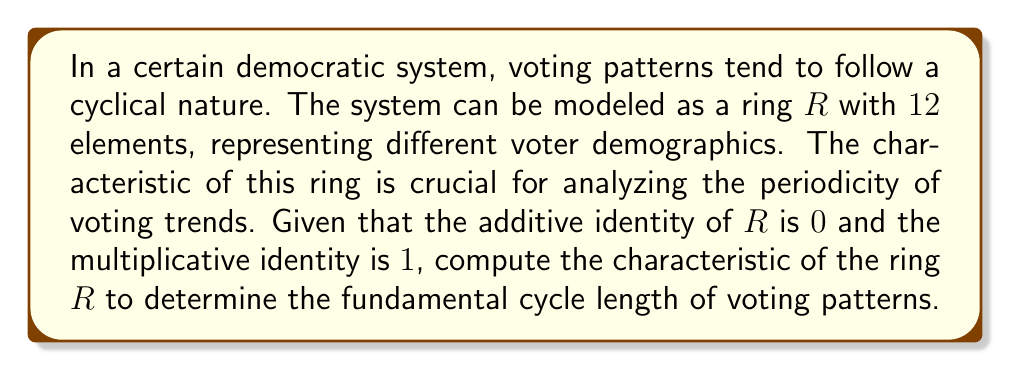Solve this math problem. To compute the characteristic of a ring $R$, we need to find the smallest positive integer $n$ such that:

$$n \cdot 1 = 0$$

where $1$ is the multiplicative identity and $0$ is the additive identity of the ring.

Let's proceed step-by-step:

1) We start by adding $1$ to itself repeatedly:

   $1 + 1 = 2$
   $2 + 1 = 3$
   $3 + 1 = 4$
   ...

2) We continue this process until we reach $0$:

   $10 + 1 = 11$
   $11 + 1 = 0$

3) We found that $12 \cdot 1 = 0$

4) Now, we need to check if there's any smaller positive integer that satisfies this condition:

   $6 \cdot 1 = 6 \neq 0$
   $4 \cdot 1 = 4 \neq 0$
   $3 \cdot 1 = 3 \neq 0$
   $2 \cdot 1 = 2 \neq 0$

5) Since no smaller positive integer satisfies the condition, we conclude that the characteristic of the ring is 12.

This result indicates that the voting patterns in this system have a fundamental cycle length of 12, which could represent, for example, a 12-year cycle in voter behavior or preferences.
Answer: The characteristic of the ring $R$ is $12$. 